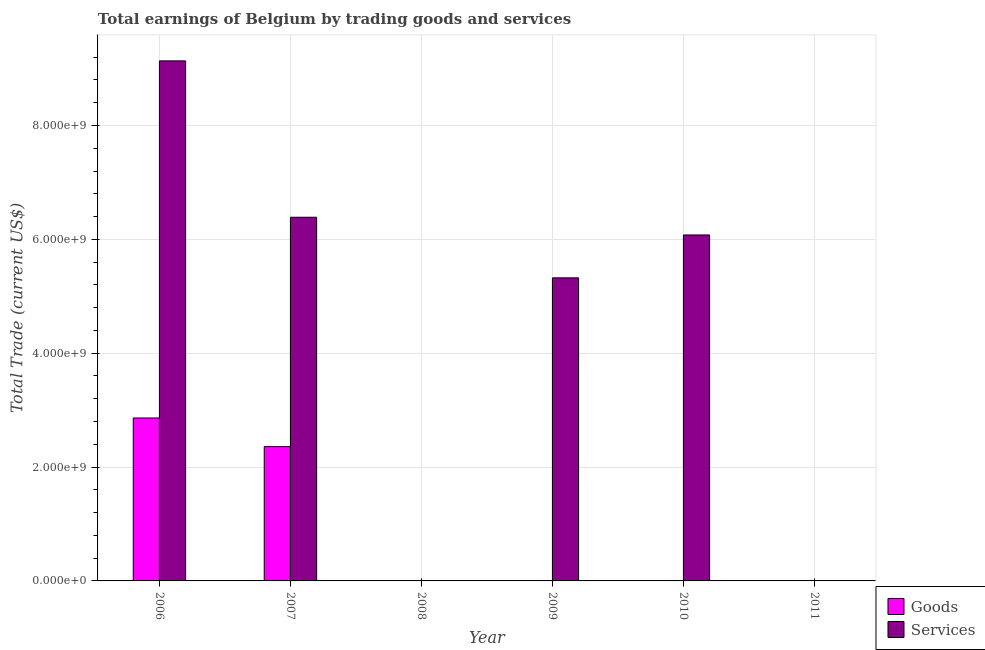How many different coloured bars are there?
Ensure brevity in your answer.  2. Are the number of bars per tick equal to the number of legend labels?
Your answer should be very brief. No. Are the number of bars on each tick of the X-axis equal?
Make the answer very short. No. How many bars are there on the 5th tick from the right?
Provide a short and direct response. 2. What is the amount earned by trading services in 2008?
Provide a short and direct response. 0. Across all years, what is the maximum amount earned by trading services?
Offer a very short reply. 9.14e+09. What is the total amount earned by trading services in the graph?
Keep it short and to the point. 2.69e+1. What is the difference between the amount earned by trading services in 2009 and that in 2010?
Provide a short and direct response. -7.54e+08. What is the difference between the amount earned by trading services in 2006 and the amount earned by trading goods in 2008?
Your response must be concise. 9.14e+09. What is the average amount earned by trading goods per year?
Ensure brevity in your answer.  8.70e+08. In how many years, is the amount earned by trading goods greater than 1200000000 US$?
Make the answer very short. 2. What is the ratio of the amount earned by trading services in 2007 to that in 2009?
Provide a succinct answer. 1.2. What is the difference between the highest and the lowest amount earned by trading goods?
Provide a succinct answer. 2.86e+09. In how many years, is the amount earned by trading services greater than the average amount earned by trading services taken over all years?
Offer a terse response. 4. Is the sum of the amount earned by trading services in 2007 and 2010 greater than the maximum amount earned by trading goods across all years?
Your answer should be compact. Yes. How many years are there in the graph?
Your response must be concise. 6. Are the values on the major ticks of Y-axis written in scientific E-notation?
Offer a very short reply. Yes. Does the graph contain any zero values?
Offer a very short reply. Yes. How are the legend labels stacked?
Give a very brief answer. Vertical. What is the title of the graph?
Give a very brief answer. Total earnings of Belgium by trading goods and services. Does "Excluding technical cooperation" appear as one of the legend labels in the graph?
Your response must be concise. No. What is the label or title of the Y-axis?
Your response must be concise. Total Trade (current US$). What is the Total Trade (current US$) of Goods in 2006?
Make the answer very short. 2.86e+09. What is the Total Trade (current US$) in Services in 2006?
Keep it short and to the point. 9.14e+09. What is the Total Trade (current US$) of Goods in 2007?
Provide a short and direct response. 2.36e+09. What is the Total Trade (current US$) of Services in 2007?
Ensure brevity in your answer.  6.39e+09. What is the Total Trade (current US$) of Goods in 2009?
Offer a very short reply. 0. What is the Total Trade (current US$) of Services in 2009?
Make the answer very short. 5.32e+09. What is the Total Trade (current US$) of Services in 2010?
Keep it short and to the point. 6.08e+09. What is the Total Trade (current US$) in Services in 2011?
Keep it short and to the point. 0. Across all years, what is the maximum Total Trade (current US$) of Goods?
Provide a short and direct response. 2.86e+09. Across all years, what is the maximum Total Trade (current US$) in Services?
Make the answer very short. 9.14e+09. What is the total Total Trade (current US$) in Goods in the graph?
Ensure brevity in your answer.  5.22e+09. What is the total Total Trade (current US$) of Services in the graph?
Make the answer very short. 2.69e+1. What is the difference between the Total Trade (current US$) in Goods in 2006 and that in 2007?
Offer a terse response. 5.03e+08. What is the difference between the Total Trade (current US$) of Services in 2006 and that in 2007?
Ensure brevity in your answer.  2.75e+09. What is the difference between the Total Trade (current US$) of Services in 2006 and that in 2009?
Provide a succinct answer. 3.81e+09. What is the difference between the Total Trade (current US$) of Services in 2006 and that in 2010?
Make the answer very short. 3.06e+09. What is the difference between the Total Trade (current US$) of Services in 2007 and that in 2009?
Offer a very short reply. 1.06e+09. What is the difference between the Total Trade (current US$) of Services in 2007 and that in 2010?
Your answer should be very brief. 3.11e+08. What is the difference between the Total Trade (current US$) of Services in 2009 and that in 2010?
Your response must be concise. -7.54e+08. What is the difference between the Total Trade (current US$) of Goods in 2006 and the Total Trade (current US$) of Services in 2007?
Your answer should be compact. -3.53e+09. What is the difference between the Total Trade (current US$) in Goods in 2006 and the Total Trade (current US$) in Services in 2009?
Provide a succinct answer. -2.46e+09. What is the difference between the Total Trade (current US$) in Goods in 2006 and the Total Trade (current US$) in Services in 2010?
Keep it short and to the point. -3.22e+09. What is the difference between the Total Trade (current US$) in Goods in 2007 and the Total Trade (current US$) in Services in 2009?
Offer a terse response. -2.96e+09. What is the difference between the Total Trade (current US$) of Goods in 2007 and the Total Trade (current US$) of Services in 2010?
Give a very brief answer. -3.72e+09. What is the average Total Trade (current US$) of Goods per year?
Provide a short and direct response. 8.70e+08. What is the average Total Trade (current US$) in Services per year?
Make the answer very short. 4.49e+09. In the year 2006, what is the difference between the Total Trade (current US$) in Goods and Total Trade (current US$) in Services?
Your answer should be compact. -6.27e+09. In the year 2007, what is the difference between the Total Trade (current US$) in Goods and Total Trade (current US$) in Services?
Offer a terse response. -4.03e+09. What is the ratio of the Total Trade (current US$) of Goods in 2006 to that in 2007?
Your answer should be very brief. 1.21. What is the ratio of the Total Trade (current US$) of Services in 2006 to that in 2007?
Ensure brevity in your answer.  1.43. What is the ratio of the Total Trade (current US$) of Services in 2006 to that in 2009?
Your answer should be compact. 1.72. What is the ratio of the Total Trade (current US$) in Services in 2006 to that in 2010?
Keep it short and to the point. 1.5. What is the ratio of the Total Trade (current US$) in Services in 2007 to that in 2009?
Ensure brevity in your answer.  1.2. What is the ratio of the Total Trade (current US$) in Services in 2007 to that in 2010?
Offer a very short reply. 1.05. What is the ratio of the Total Trade (current US$) of Services in 2009 to that in 2010?
Provide a succinct answer. 0.88. What is the difference between the highest and the second highest Total Trade (current US$) in Services?
Your response must be concise. 2.75e+09. What is the difference between the highest and the lowest Total Trade (current US$) of Goods?
Give a very brief answer. 2.86e+09. What is the difference between the highest and the lowest Total Trade (current US$) of Services?
Offer a terse response. 9.14e+09. 